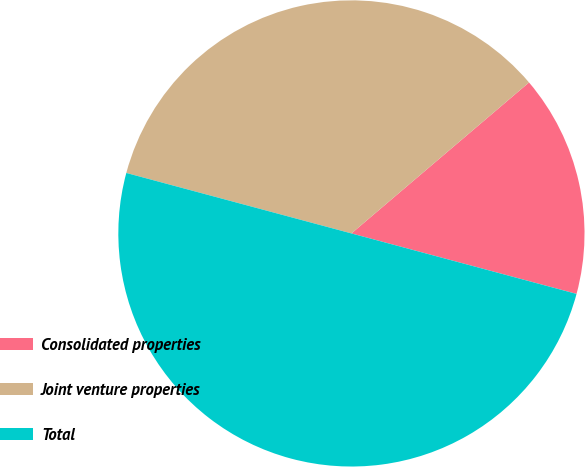Convert chart to OTSL. <chart><loc_0><loc_0><loc_500><loc_500><pie_chart><fcel>Consolidated properties<fcel>Joint venture properties<fcel>Total<nl><fcel>15.39%<fcel>34.61%<fcel>50.0%<nl></chart> 